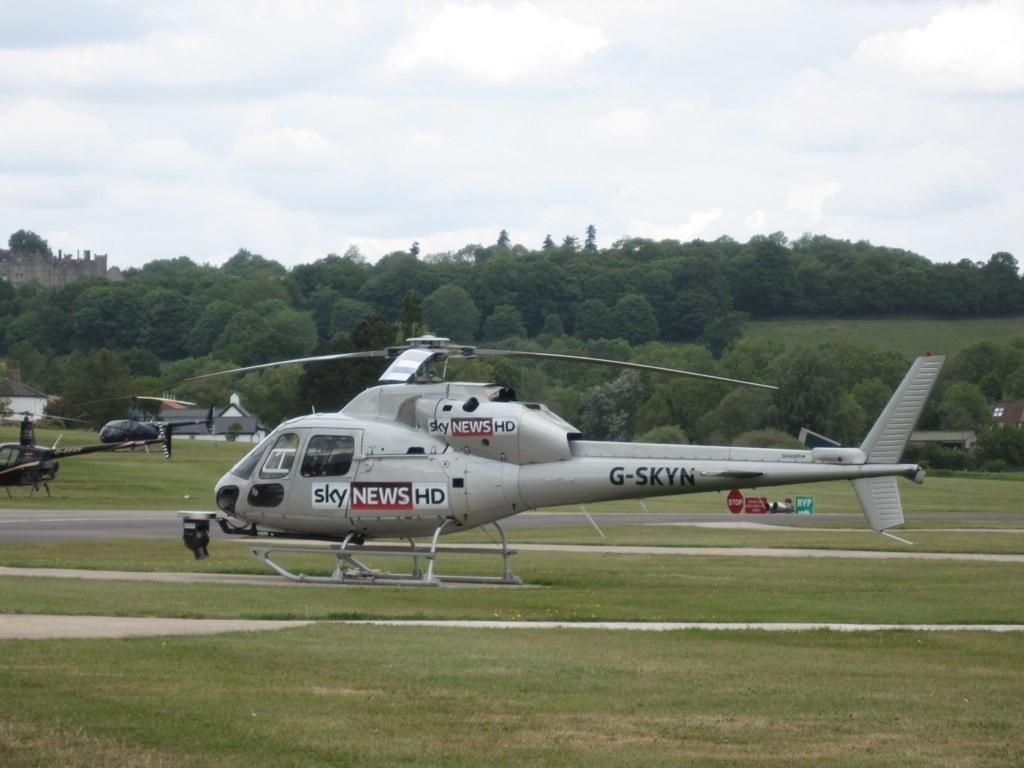What is the main subject of the image? The main subject of the image is three helicopters. Where are the helicopters located in the image? The helicopters are in the middle of the image. What can be seen in the background of the image? There are trees in the background of the image. What is visible at the top of the image? The sky is visible at the top of the image. Can you hear the whistle of the helicopters in the image? There is no mention of a whistle in the image, so it cannot be heard. 